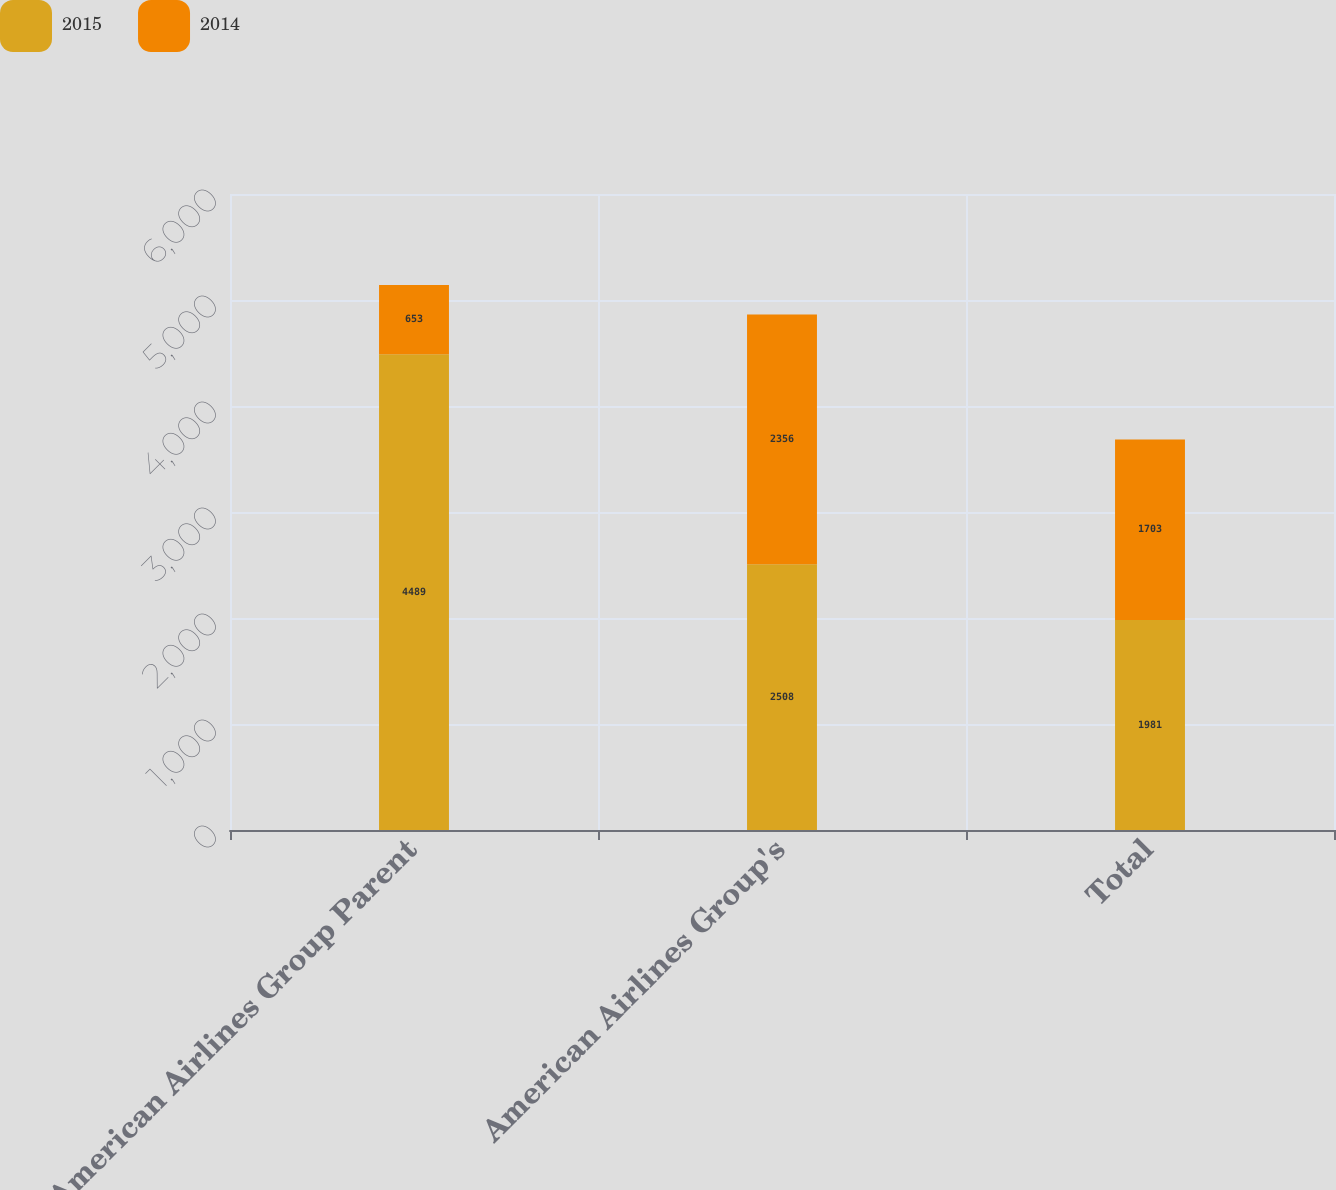Convert chart. <chart><loc_0><loc_0><loc_500><loc_500><stacked_bar_chart><ecel><fcel>American Airlines Group Parent<fcel>American Airlines Group's<fcel>Total<nl><fcel>2015<fcel>4489<fcel>2508<fcel>1981<nl><fcel>2014<fcel>653<fcel>2356<fcel>1703<nl></chart> 